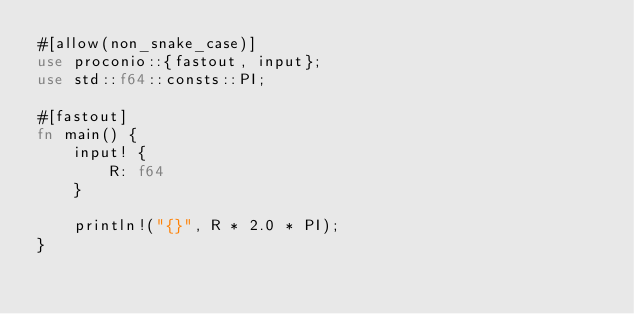<code> <loc_0><loc_0><loc_500><loc_500><_Rust_>#[allow(non_snake_case)]
use proconio::{fastout, input};
use std::f64::consts::PI;

#[fastout]
fn main() {
    input! {
        R: f64
    }

    println!("{}", R * 2.0 * PI);
}
</code> 